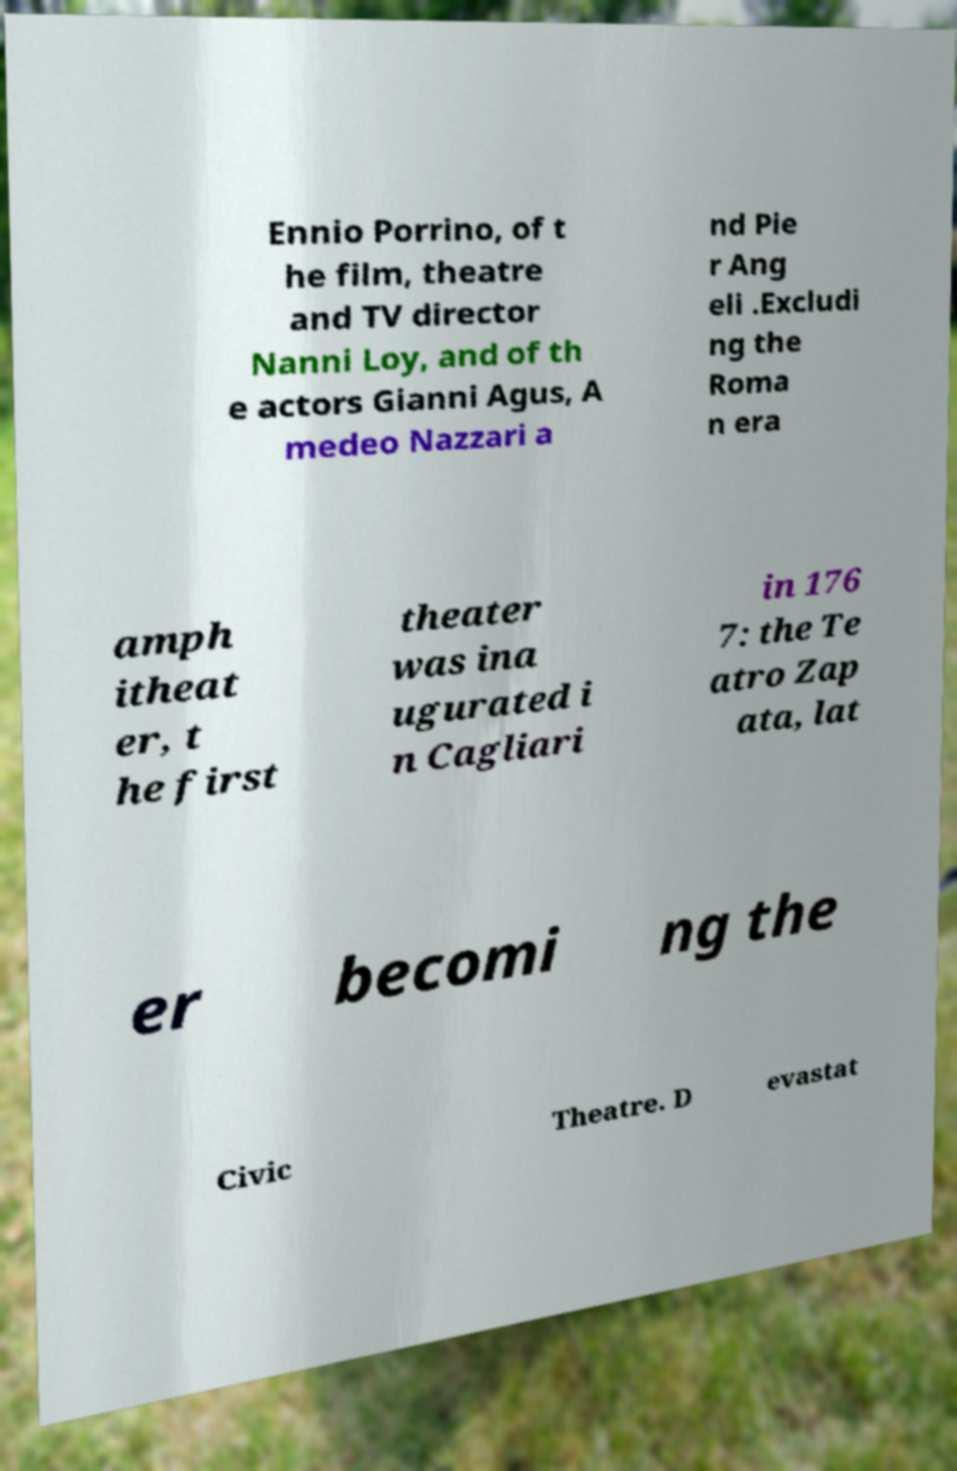I need the written content from this picture converted into text. Can you do that? Ennio Porrino, of t he film, theatre and TV director Nanni Loy, and of th e actors Gianni Agus, A medeo Nazzari a nd Pie r Ang eli .Excludi ng the Roma n era amph itheat er, t he first theater was ina ugurated i n Cagliari in 176 7: the Te atro Zap ata, lat er becomi ng the Civic Theatre. D evastat 